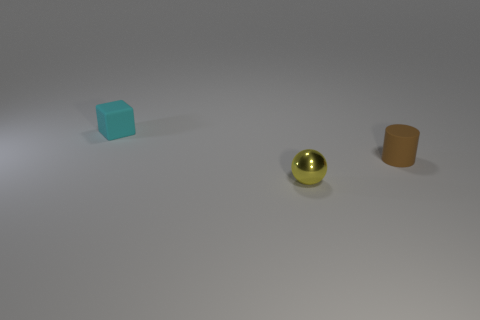There is a small object in front of the tiny matte object right of the small matte thing behind the tiny cylinder; what is its color? yellow 